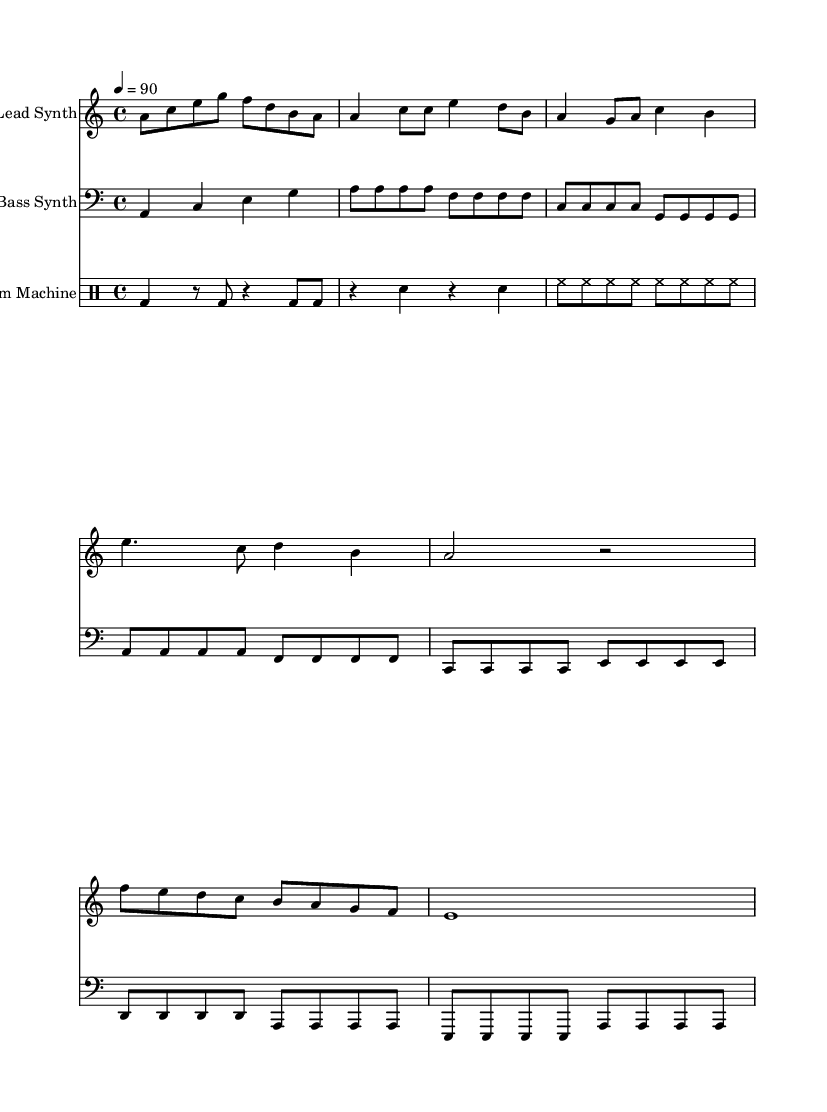What is the key signature of this music? The key signature indicates the music is in A minor, which contains no sharps or flats.
Answer: A minor What is the time signature used in this piece? The time signature is 4/4, as indicated at the beginning of the sheet music.
Answer: 4/4 What is the tempo marking for this music? The tempo marking shows 4 beats per minute, specifying a speed of 90 beats per minute.
Answer: 90 How many measures are in the verse section? The verse section consists of two measures, as shown in the lead synth part.
Answer: 2 What type of musical ensemble is represented here? The music consists of a lead synth, bass synth, and a drum machine, indicating a modern electronic ensemble often used in rap.
Answer: Electronic ensemble What is the pattern of the drum used in the intro? The drum pattern for the intro primarily features bass drums played on the first and third beats with rests in between.
Answer: Bass drum What instruments are indicated for this rap piece? The instruments indicated for the piece are a lead synth, bass synth, and a drum machine, typical for rap music production.
Answer: Lead synth, bass synth, drum machine 